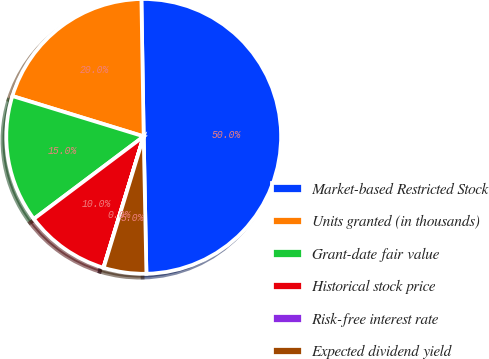Convert chart. <chart><loc_0><loc_0><loc_500><loc_500><pie_chart><fcel>Market-based Restricted Stock<fcel>Units granted (in thousands)<fcel>Grant-date fair value<fcel>Historical stock price<fcel>Risk-free interest rate<fcel>Expected dividend yield<nl><fcel>49.95%<fcel>19.99%<fcel>15.0%<fcel>10.01%<fcel>0.03%<fcel>5.02%<nl></chart> 